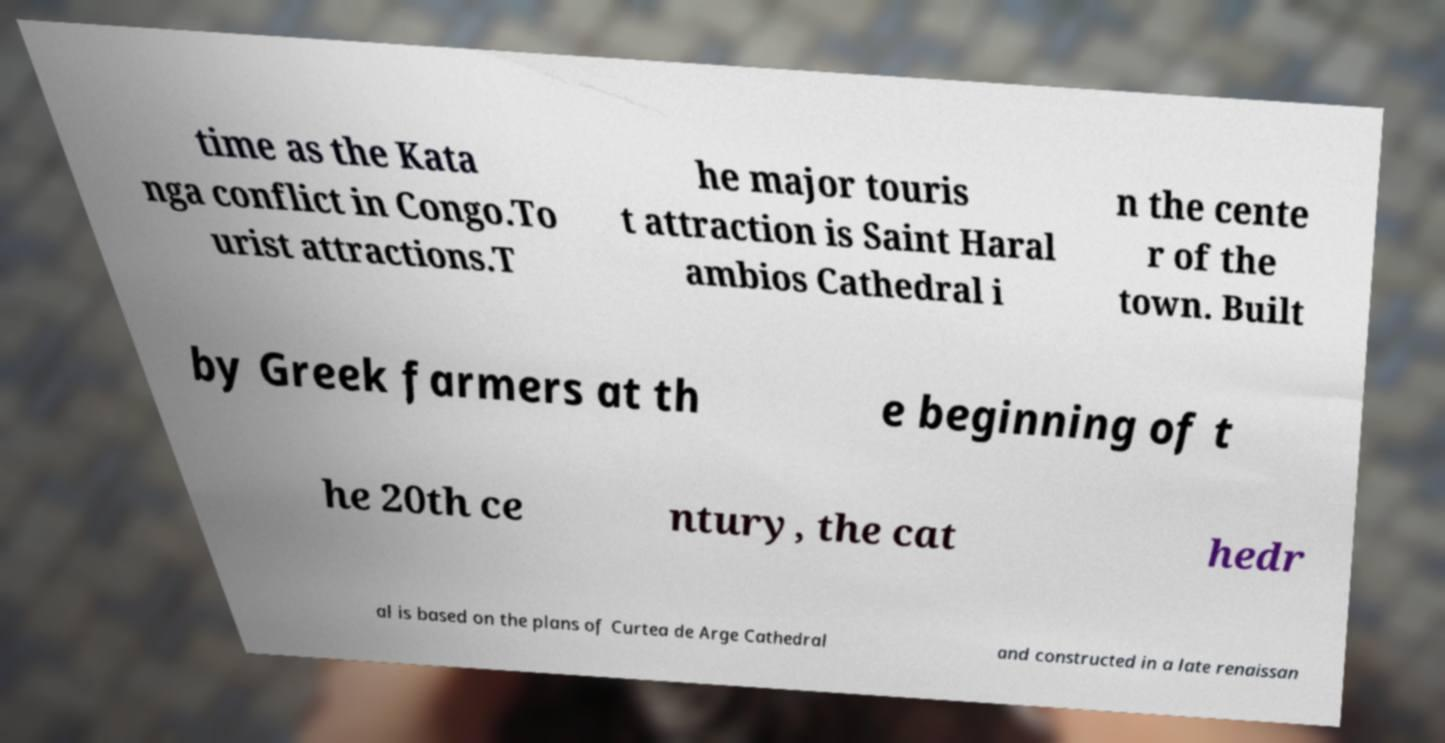What messages or text are displayed in this image? I need them in a readable, typed format. time as the Kata nga conflict in Congo.To urist attractions.T he major touris t attraction is Saint Haral ambios Cathedral i n the cente r of the town. Built by Greek farmers at th e beginning of t he 20th ce ntury, the cat hedr al is based on the plans of Curtea de Arge Cathedral and constructed in a late renaissan 